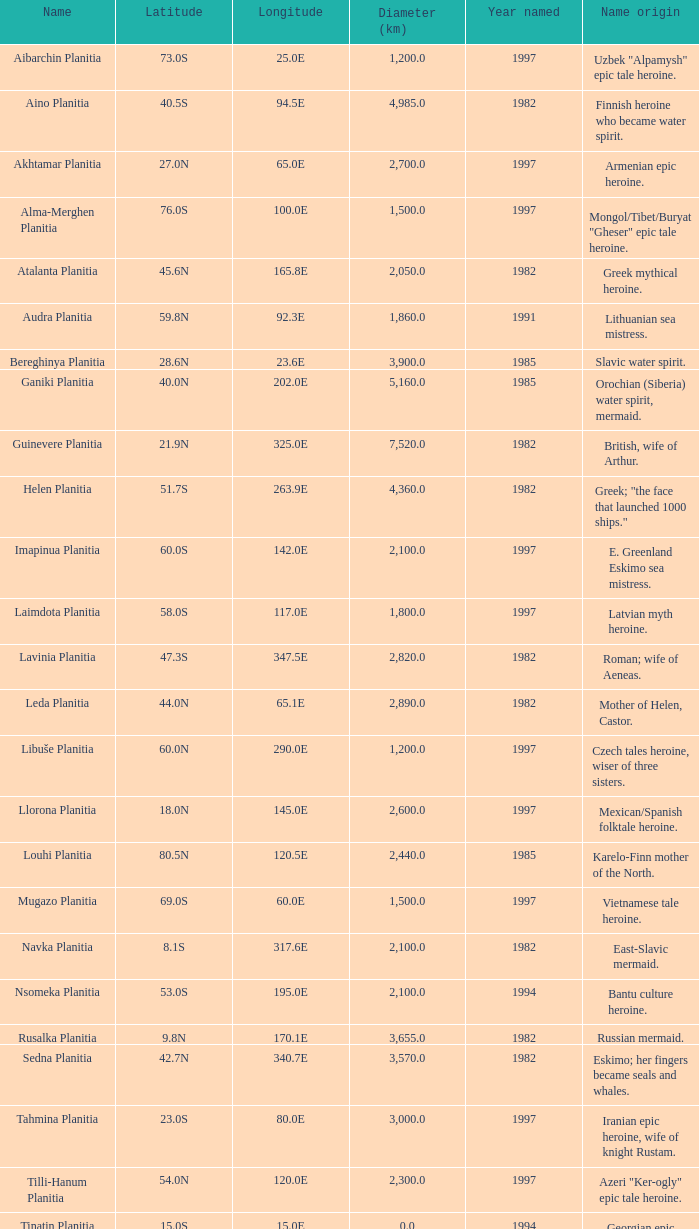0 km? Karelo-Finn mermaid. 